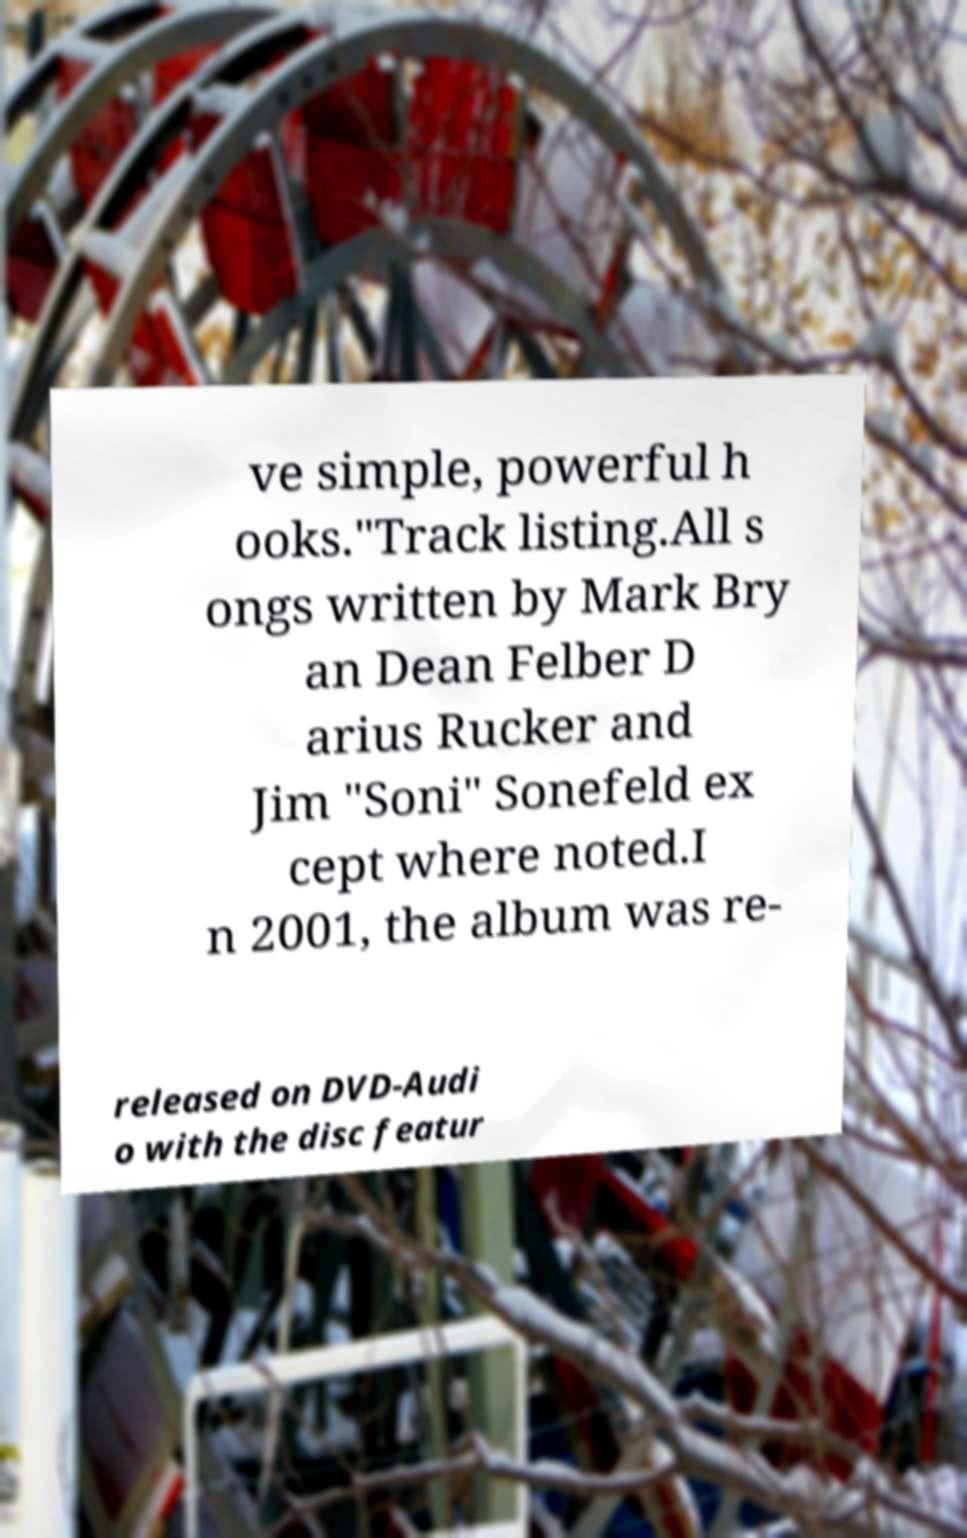There's text embedded in this image that I need extracted. Can you transcribe it verbatim? ve simple, powerful h ooks."Track listing.All s ongs written by Mark Bry an Dean Felber D arius Rucker and Jim "Soni" Sonefeld ex cept where noted.I n 2001, the album was re- released on DVD-Audi o with the disc featur 